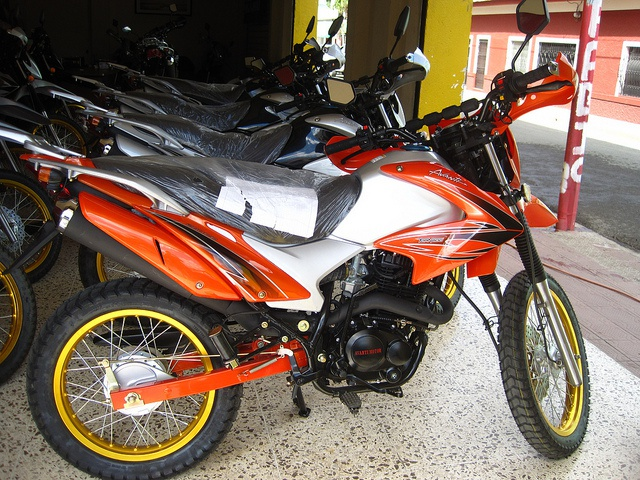Describe the objects in this image and their specific colors. I can see motorcycle in black, white, gray, and red tones, motorcycle in black, gray, darkgray, and darkgreen tones, motorcycle in black, gray, lightgray, and darkgray tones, motorcycle in black and gray tones, and motorcycle in black, gray, darkgray, and maroon tones in this image. 